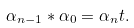<formula> <loc_0><loc_0><loc_500><loc_500>\alpha _ { n - 1 } \ast \alpha _ { 0 } = \alpha _ { n } t .</formula> 